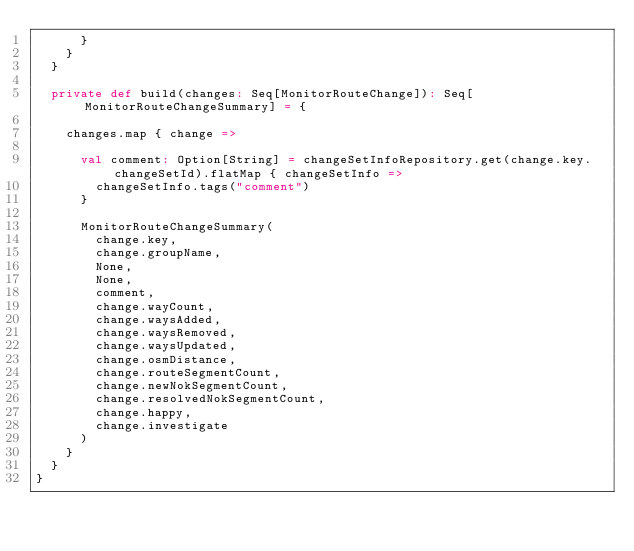<code> <loc_0><loc_0><loc_500><loc_500><_Scala_>      }
    }
  }

  private def build(changes: Seq[MonitorRouteChange]): Seq[MonitorRouteChangeSummary] = {

    changes.map { change =>

      val comment: Option[String] = changeSetInfoRepository.get(change.key.changeSetId).flatMap { changeSetInfo =>
        changeSetInfo.tags("comment")
      }

      MonitorRouteChangeSummary(
        change.key,
        change.groupName,
        None,
        None,
        comment,
        change.wayCount,
        change.waysAdded,
        change.waysRemoved,
        change.waysUpdated,
        change.osmDistance,
        change.routeSegmentCount,
        change.newNokSegmentCount,
        change.resolvedNokSegmentCount,
        change.happy,
        change.investigate
      )
    }
  }
}
</code> 